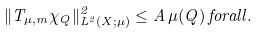<formula> <loc_0><loc_0><loc_500><loc_500>\| T _ { \mu , m } \chi _ { Q } \| _ { L ^ { 2 } ( X ; \mu ) } ^ { 2 } \leq A \, \mu ( Q ) \, f o r a l l .</formula> 